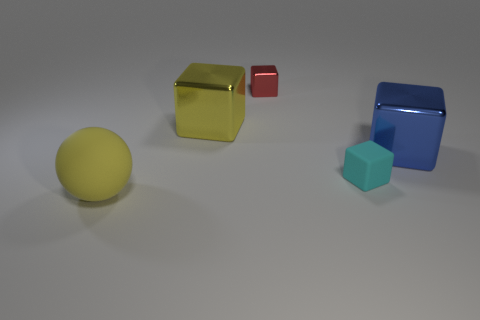Is there a blue thing made of the same material as the small cyan object?
Keep it short and to the point. No. What is the size of the blue metal thing?
Ensure brevity in your answer.  Large. There is a yellow matte ball in front of the large cube that is behind the blue metallic object; how big is it?
Give a very brief answer. Large. What is the material of the cyan thing that is the same shape as the blue object?
Your answer should be compact. Rubber. What number of objects are there?
Keep it short and to the point. 5. There is a large metallic block that is on the right side of the tiny red thing that is behind the shiny cube to the right of the small cyan cube; what color is it?
Your answer should be very brief. Blue. Are there fewer large blue metal balls than big shiny things?
Your response must be concise. Yes. What color is the other large thing that is the same shape as the blue shiny thing?
Your answer should be compact. Yellow. There is a large thing that is made of the same material as the large yellow block; what color is it?
Provide a succinct answer. Blue. What number of blue metal cubes have the same size as the cyan object?
Keep it short and to the point. 0. 